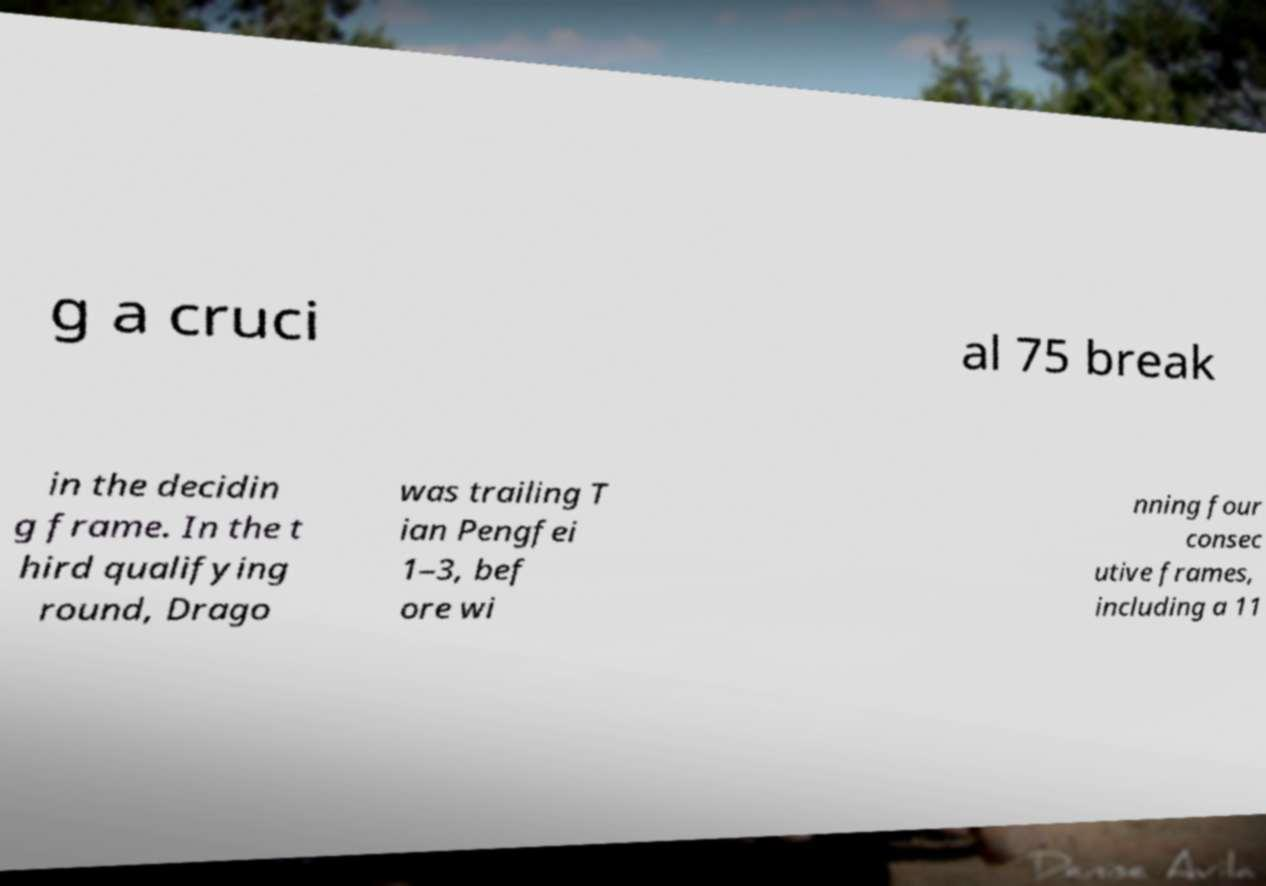Please identify and transcribe the text found in this image. g a cruci al 75 break in the decidin g frame. In the t hird qualifying round, Drago was trailing T ian Pengfei 1–3, bef ore wi nning four consec utive frames, including a 11 